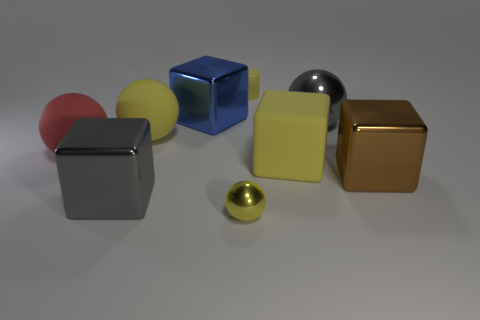Subtract 2 spheres. How many spheres are left? 2 Subtract all red balls. How many balls are left? 3 Subtract all cyan blocks. Subtract all blue cylinders. How many blocks are left? 4 Add 1 tiny matte things. How many objects exist? 10 Subtract all cylinders. How many objects are left? 8 Add 4 metallic blocks. How many metallic blocks exist? 7 Subtract 0 purple cylinders. How many objects are left? 9 Subtract all large blue cubes. Subtract all small yellow rubber things. How many objects are left? 7 Add 4 tiny matte things. How many tiny matte things are left? 5 